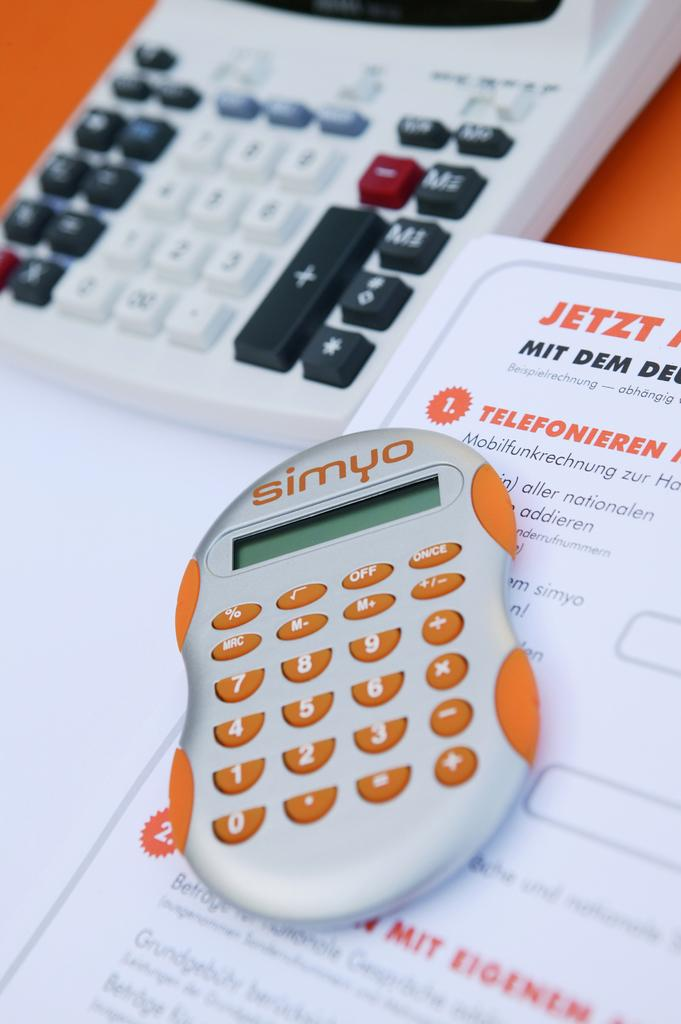<image>
Describe the image concisely. a small calculator that is silver and orange and labeled 'simyo' at the top 